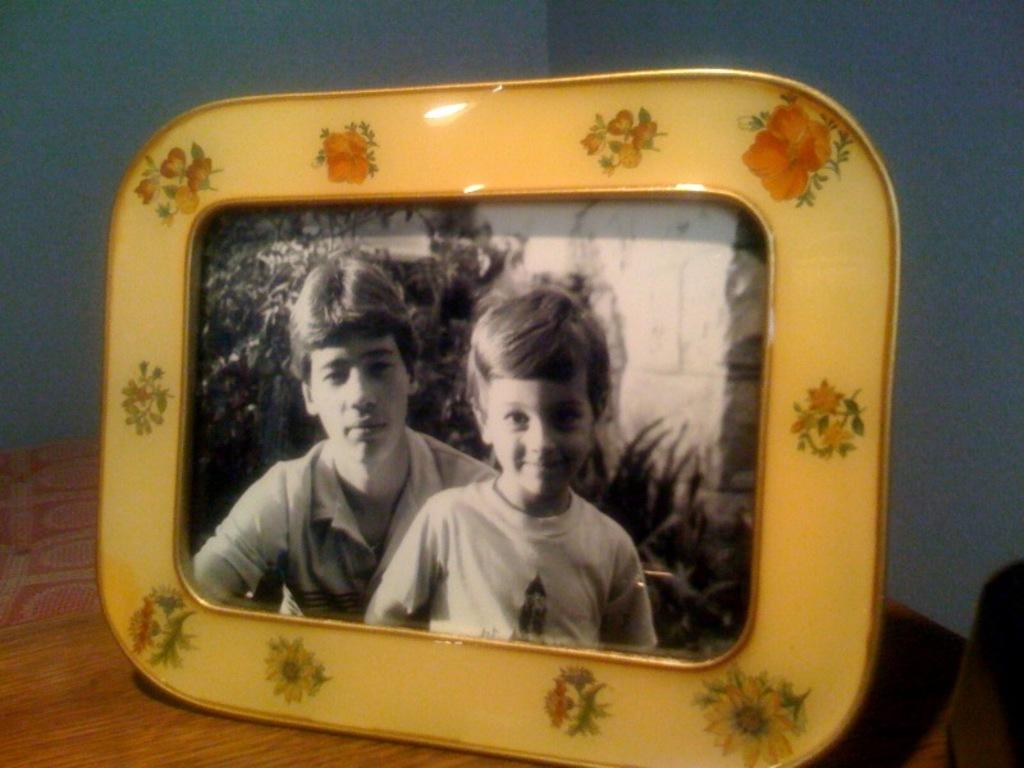What is the main piece of furniture in the image? There is a table in the image. What is placed on the table? There is a photo frame on the table. What is depicted in the photo frame? The photo frame contains a picture of two people and plants. What can be seen in the background of the image? There is a wall in the background of the image. What type of pest can be seen crawling on the wall in the image? There is no pest visible in the image; only a wall is present in the background. Can you tell me how many geese are depicted in the photo frame? There are no geese depicted in the photo frame; it contains a picture of two people and plants. 